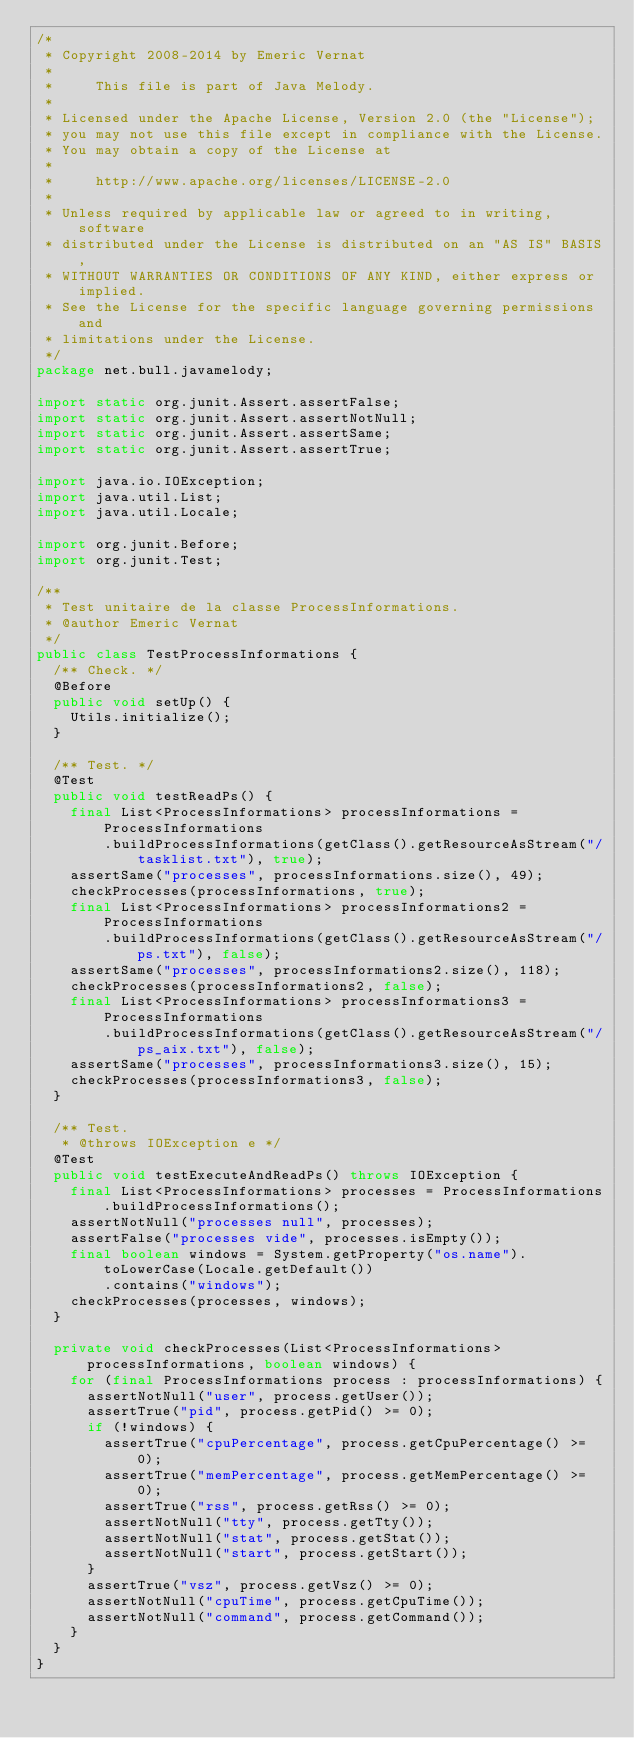Convert code to text. <code><loc_0><loc_0><loc_500><loc_500><_Java_>/*
 * Copyright 2008-2014 by Emeric Vernat
 *
 *     This file is part of Java Melody.
 *
 * Licensed under the Apache License, Version 2.0 (the "License");
 * you may not use this file except in compliance with the License.
 * You may obtain a copy of the License at
 *
 *     http://www.apache.org/licenses/LICENSE-2.0
 *
 * Unless required by applicable law or agreed to in writing, software
 * distributed under the License is distributed on an "AS IS" BASIS,
 * WITHOUT WARRANTIES OR CONDITIONS OF ANY KIND, either express or implied.
 * See the License for the specific language governing permissions and
 * limitations under the License.
 */
package net.bull.javamelody;

import static org.junit.Assert.assertFalse;
import static org.junit.Assert.assertNotNull;
import static org.junit.Assert.assertSame;
import static org.junit.Assert.assertTrue;

import java.io.IOException;
import java.util.List;
import java.util.Locale;

import org.junit.Before;
import org.junit.Test;

/**
 * Test unitaire de la classe ProcessInformations.
 * @author Emeric Vernat
 */
public class TestProcessInformations {
	/** Check. */
	@Before
	public void setUp() {
		Utils.initialize();
	}

	/** Test. */
	@Test
	public void testReadPs() {
		final List<ProcessInformations> processInformations = ProcessInformations
				.buildProcessInformations(getClass().getResourceAsStream("/tasklist.txt"), true);
		assertSame("processes", processInformations.size(), 49);
		checkProcesses(processInformations, true);
		final List<ProcessInformations> processInformations2 = ProcessInformations
				.buildProcessInformations(getClass().getResourceAsStream("/ps.txt"), false);
		assertSame("processes", processInformations2.size(), 118);
		checkProcesses(processInformations2, false);
		final List<ProcessInformations> processInformations3 = ProcessInformations
				.buildProcessInformations(getClass().getResourceAsStream("/ps_aix.txt"), false);
		assertSame("processes", processInformations3.size(), 15);
		checkProcesses(processInformations3, false);
	}

	/** Test.
	 * @throws IOException e */
	@Test
	public void testExecuteAndReadPs() throws IOException {
		final List<ProcessInformations> processes = ProcessInformations.buildProcessInformations();
		assertNotNull("processes null", processes);
		assertFalse("processes vide", processes.isEmpty());
		final boolean windows = System.getProperty("os.name").toLowerCase(Locale.getDefault())
				.contains("windows");
		checkProcesses(processes, windows);
	}

	private void checkProcesses(List<ProcessInformations> processInformations, boolean windows) {
		for (final ProcessInformations process : processInformations) {
			assertNotNull("user", process.getUser());
			assertTrue("pid", process.getPid() >= 0);
			if (!windows) {
				assertTrue("cpuPercentage", process.getCpuPercentage() >= 0);
				assertTrue("memPercentage", process.getMemPercentage() >= 0);
				assertTrue("rss", process.getRss() >= 0);
				assertNotNull("tty", process.getTty());
				assertNotNull("stat", process.getStat());
				assertNotNull("start", process.getStart());
			}
			assertTrue("vsz", process.getVsz() >= 0);
			assertNotNull("cpuTime", process.getCpuTime());
			assertNotNull("command", process.getCommand());
		}
	}
}
</code> 